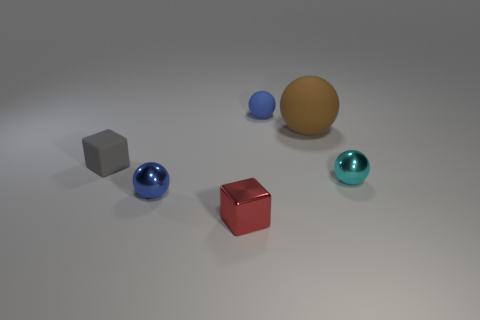Is the cyan sphere made of the same material as the tiny cube that is behind the cyan sphere?
Keep it short and to the point. No. The rubber thing that is both on the left side of the large brown rubber object and right of the tiny blue metallic thing has what shape?
Offer a very short reply. Sphere. How many other objects are the same color as the rubber cube?
Offer a very short reply. 0. There is a red metallic object; what shape is it?
Ensure brevity in your answer.  Cube. There is a matte thing that is on the left side of the blue ball behind the cyan shiny sphere; what is its color?
Provide a short and direct response. Gray. Do the tiny matte ball and the tiny metal sphere on the left side of the red thing have the same color?
Your response must be concise. Yes. The object that is both in front of the large ball and right of the blue matte ball is made of what material?
Your answer should be very brief. Metal. Is there a green ball that has the same size as the matte block?
Offer a very short reply. No. There is a red block that is the same size as the gray rubber thing; what is it made of?
Your response must be concise. Metal. There is a big brown object; how many red shiny things are in front of it?
Provide a short and direct response. 1. 